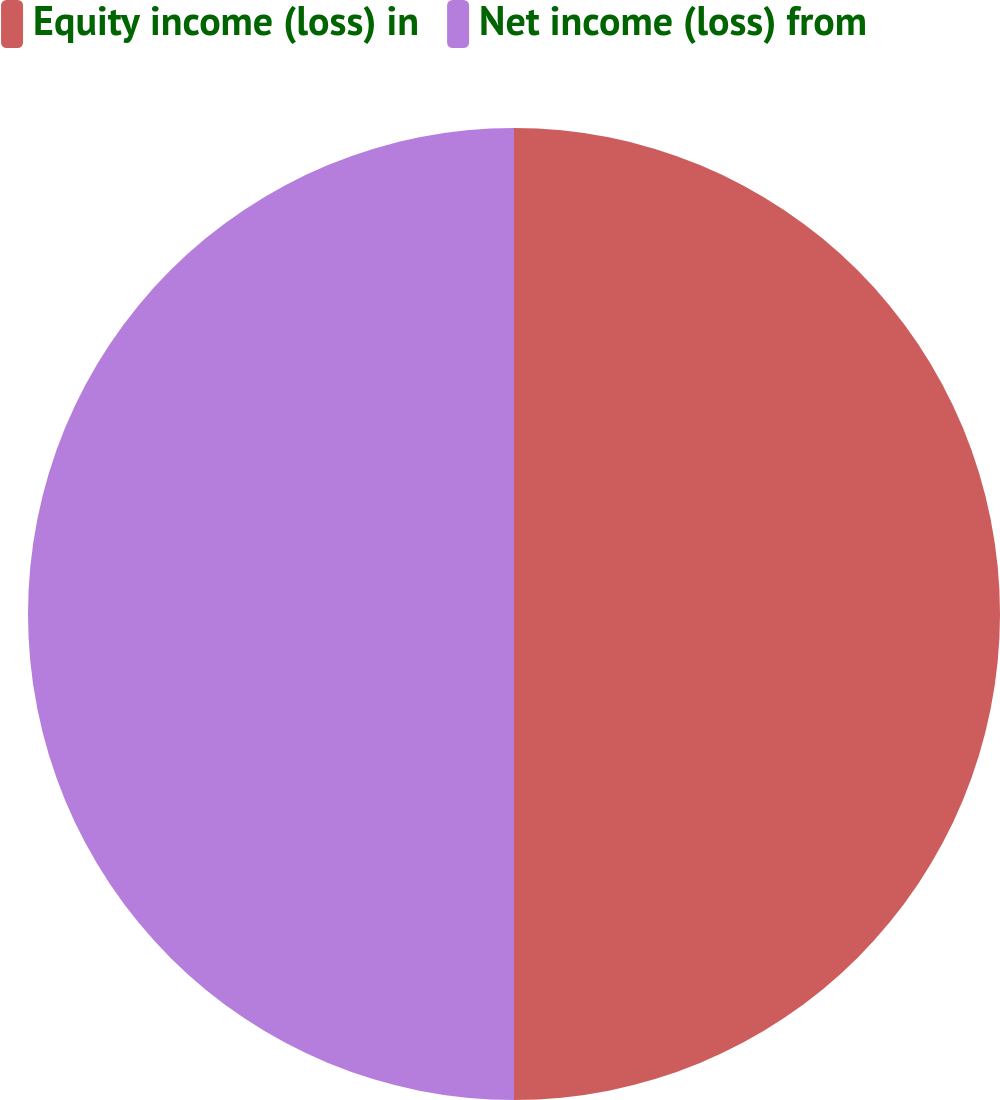Convert chart. <chart><loc_0><loc_0><loc_500><loc_500><pie_chart><fcel>Equity income (loss) in<fcel>Net income (loss) from<nl><fcel>50.0%<fcel>50.0%<nl></chart> 